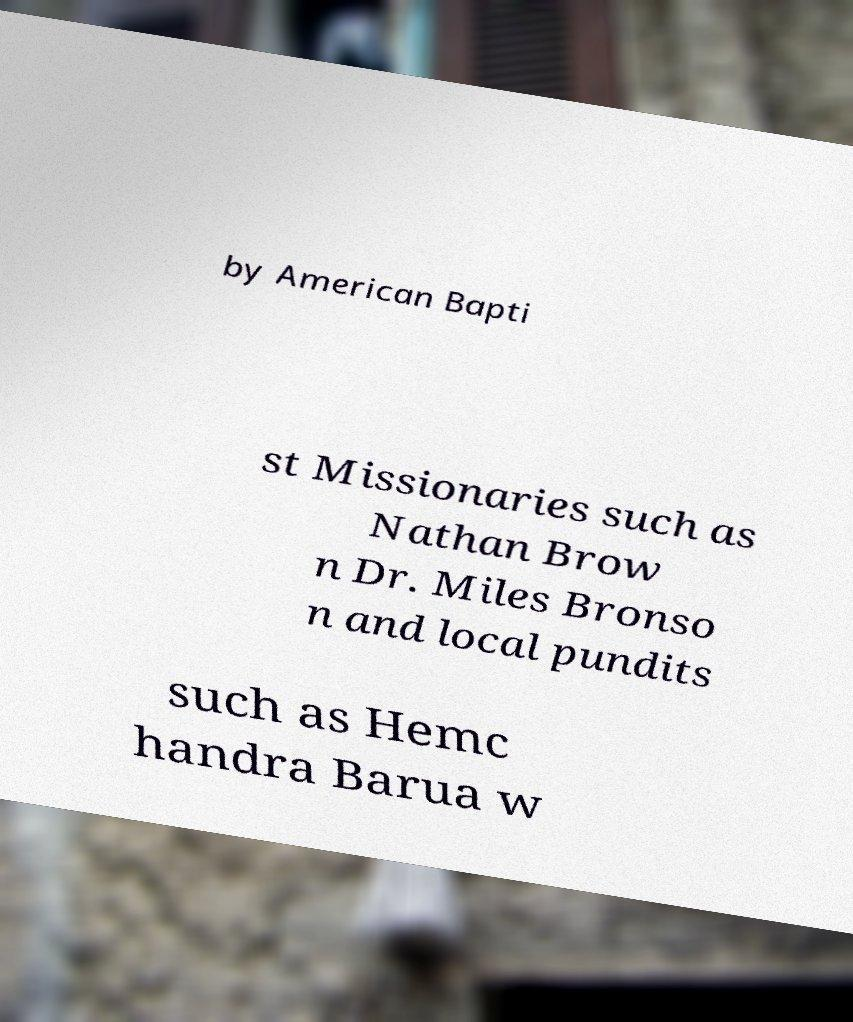There's text embedded in this image that I need extracted. Can you transcribe it verbatim? by American Bapti st Missionaries such as Nathan Brow n Dr. Miles Bronso n and local pundits such as Hemc handra Barua w 